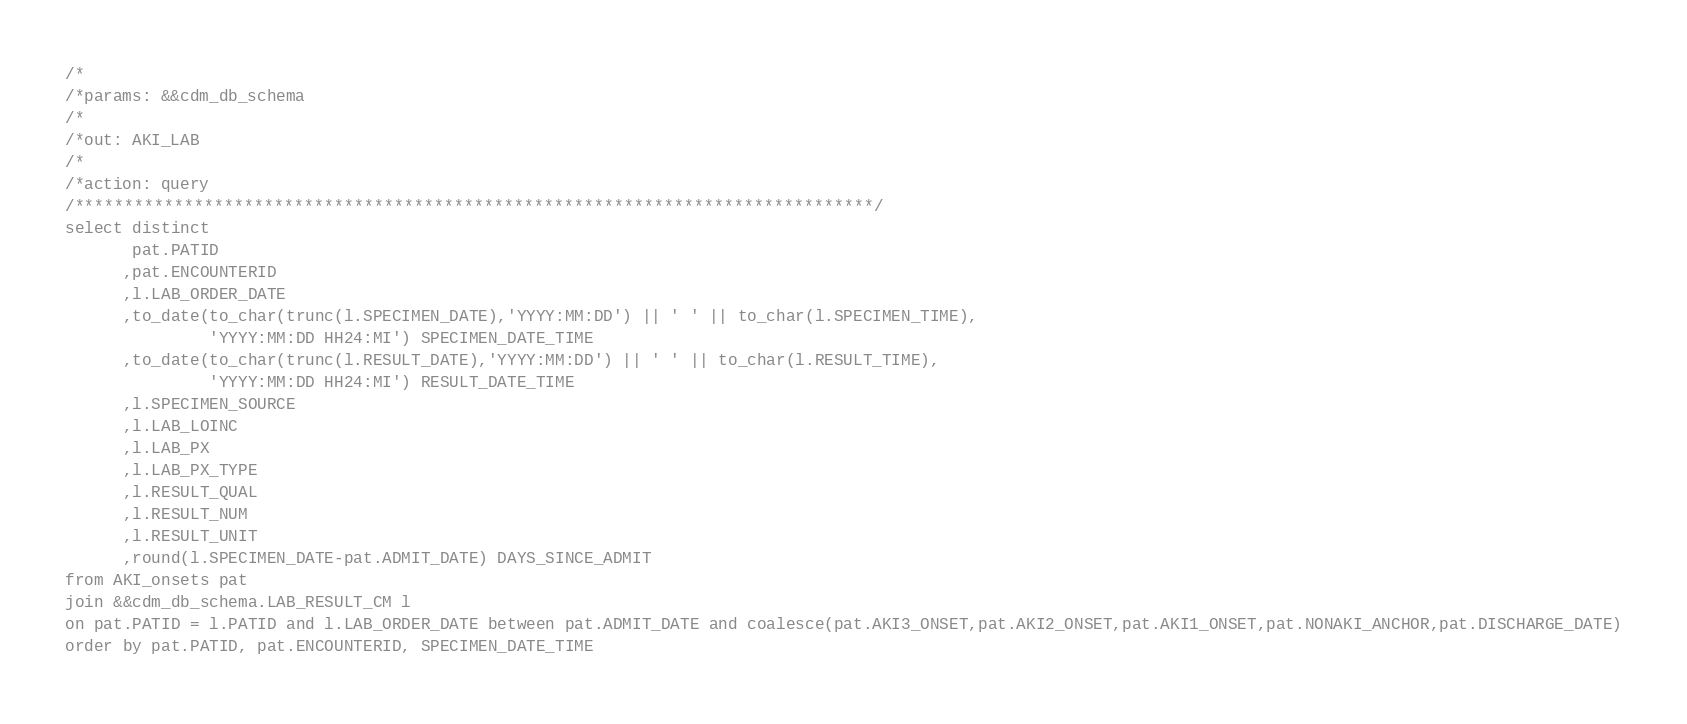<code> <loc_0><loc_0><loc_500><loc_500><_SQL_>/*
/*params: &&cdm_db_schema
/*
/*out: AKI_LAB
/*
/*action: query
/********************************************************************************/
select distinct
       pat.PATID
      ,pat.ENCOUNTERID
      ,l.LAB_ORDER_DATE
      ,to_date(to_char(trunc(l.SPECIMEN_DATE),'YYYY:MM:DD') || ' ' || to_char(l.SPECIMEN_TIME),
               'YYYY:MM:DD HH24:MI') SPECIMEN_DATE_TIME
      ,to_date(to_char(trunc(l.RESULT_DATE),'YYYY:MM:DD') || ' ' || to_char(l.RESULT_TIME),
               'YYYY:MM:DD HH24:MI') RESULT_DATE_TIME
      ,l.SPECIMEN_SOURCE
      ,l.LAB_LOINC
      ,l.LAB_PX
      ,l.LAB_PX_TYPE
      ,l.RESULT_QUAL
      ,l.RESULT_NUM
      ,l.RESULT_UNIT
      ,round(l.SPECIMEN_DATE-pat.ADMIT_DATE) DAYS_SINCE_ADMIT
from AKI_onsets pat
join &&cdm_db_schema.LAB_RESULT_CM l
on pat.PATID = l.PATID and l.LAB_ORDER_DATE between pat.ADMIT_DATE and coalesce(pat.AKI3_ONSET,pat.AKI2_ONSET,pat.AKI1_ONSET,pat.NONAKI_ANCHOR,pat.DISCHARGE_DATE)
order by pat.PATID, pat.ENCOUNTERID, SPECIMEN_DATE_TIME


</code> 